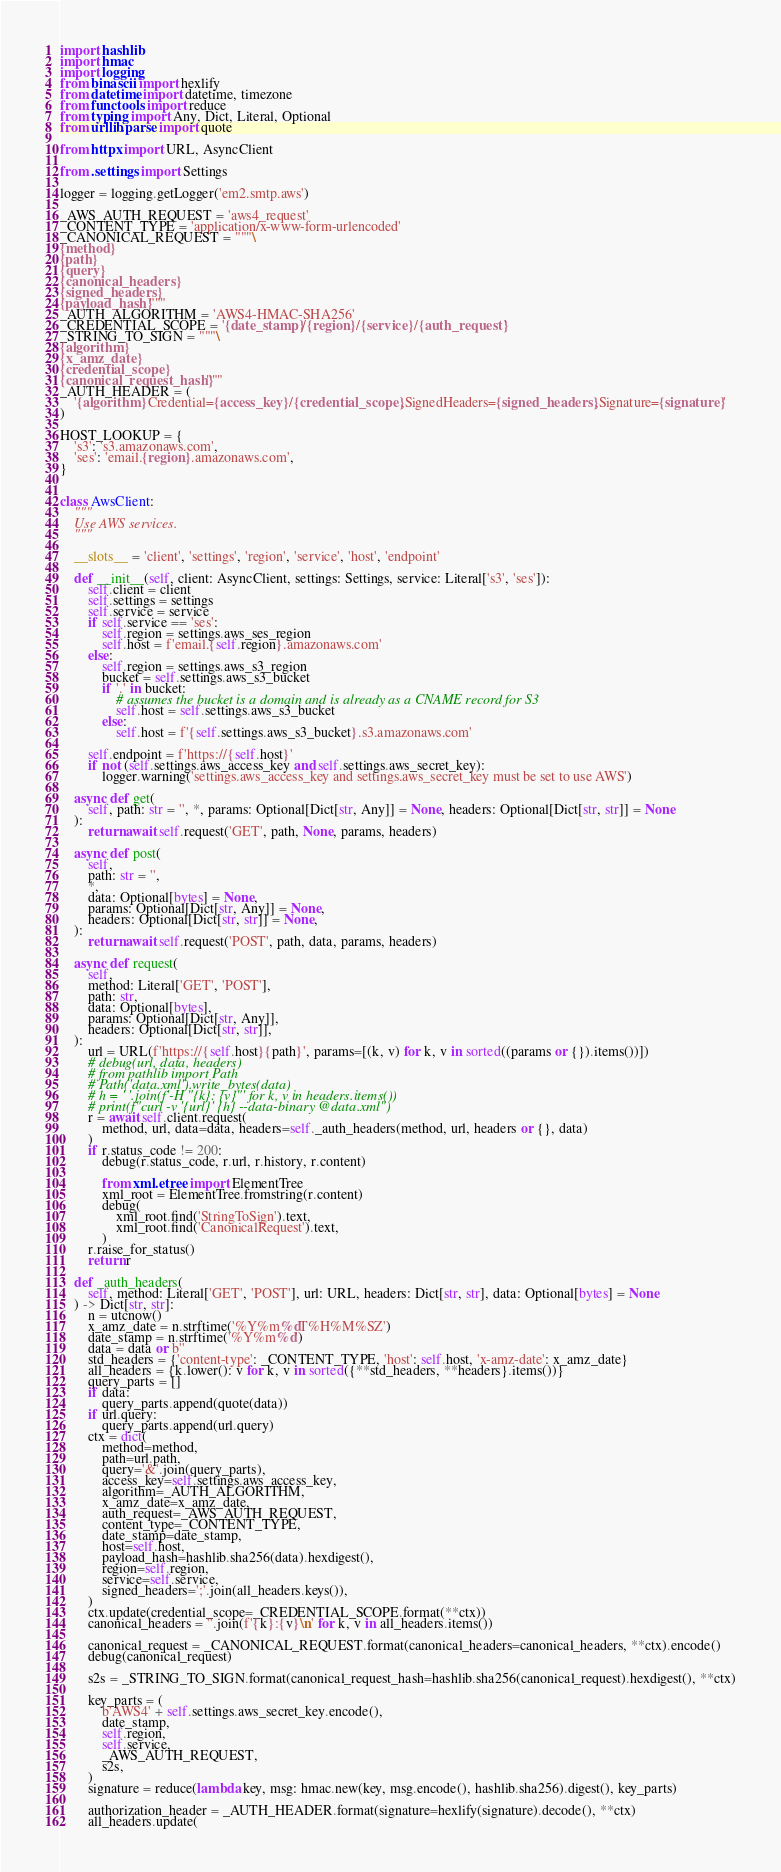Convert code to text. <code><loc_0><loc_0><loc_500><loc_500><_Python_>import hashlib
import hmac
import logging
from binascii import hexlify
from datetime import datetime, timezone
from functools import reduce
from typing import Any, Dict, Literal, Optional
from urllib.parse import quote

from httpx import URL, AsyncClient

from .settings import Settings

logger = logging.getLogger('em2.smtp.aws')

_AWS_AUTH_REQUEST = 'aws4_request'
_CONTENT_TYPE = 'application/x-www-form-urlencoded'
_CANONICAL_REQUEST = """\
{method}
{path}
{query}
{canonical_headers}
{signed_headers}
{payload_hash}"""
_AUTH_ALGORITHM = 'AWS4-HMAC-SHA256'
_CREDENTIAL_SCOPE = '{date_stamp}/{region}/{service}/{auth_request}'
_STRING_TO_SIGN = """\
{algorithm}
{x_amz_date}
{credential_scope}
{canonical_request_hash}"""
_AUTH_HEADER = (
    '{algorithm} Credential={access_key}/{credential_scope},SignedHeaders={signed_headers},Signature={signature}'
)

HOST_LOOKUP = {
    's3': 's3.amazonaws.com',
    'ses': 'email.{region}.amazonaws.com',
}


class AwsClient:
    """
    Use AWS services.
    """

    __slots__ = 'client', 'settings', 'region', 'service', 'host', 'endpoint'

    def __init__(self, client: AsyncClient, settings: Settings, service: Literal['s3', 'ses']):
        self.client = client
        self.settings = settings
        self.service = service
        if self.service == 'ses':
            self.region = settings.aws_ses_region
            self.host = f'email.{self.region}.amazonaws.com'
        else:
            self.region = settings.aws_s3_region
            bucket = self.settings.aws_s3_bucket
            if '.' in bucket:
                # assumes the bucket is a domain and is already as a CNAME record for S3
                self.host = self.settings.aws_s3_bucket
            else:
                self.host = f'{self.settings.aws_s3_bucket}.s3.amazonaws.com'

        self.endpoint = f'https://{self.host}'
        if not (self.settings.aws_access_key and self.settings.aws_secret_key):
            logger.warning('settings.aws_access_key and settings.aws_secret_key must be set to use AWS')

    async def get(
        self, path: str = '', *, params: Optional[Dict[str, Any]] = None, headers: Optional[Dict[str, str]] = None
    ):
        return await self.request('GET', path, None, params, headers)

    async def post(
        self,
        path: str = '',
        *,
        data: Optional[bytes] = None,
        params: Optional[Dict[str, Any]] = None,
        headers: Optional[Dict[str, str]] = None,
    ):
        return await self.request('POST', path, data, params, headers)

    async def request(
        self,
        method: Literal['GET', 'POST'],
        path: str,
        data: Optional[bytes],
        params: Optional[Dict[str, Any]],
        headers: Optional[Dict[str, str]],
    ):
        url = URL(f'https://{self.host}{path}', params=[(k, v) for k, v in sorted((params or {}).items())])
        # debug(url, data, headers)
        # from pathlib import Path
        # Path('data.xml').write_bytes(data)
        # h = ' '.join(f'-H "{k}: {v}"' for k, v in headers.items())
        # print(f"curl -v '{url}' {h} --data-binary @data.xml")
        r = await self.client.request(
            method, url, data=data, headers=self._auth_headers(method, url, headers or {}, data)
        )
        if r.status_code != 200:
            debug(r.status_code, r.url, r.history, r.content)

            from xml.etree import ElementTree
            xml_root = ElementTree.fromstring(r.content)
            debug(
                xml_root.find('StringToSign').text,
                xml_root.find('CanonicalRequest').text,
            )
        r.raise_for_status()
        return r

    def _auth_headers(
        self, method: Literal['GET', 'POST'], url: URL, headers: Dict[str, str], data: Optional[bytes] = None
    ) -> Dict[str, str]:
        n = utcnow()
        x_amz_date = n.strftime('%Y%m%dT%H%M%SZ')
        date_stamp = n.strftime('%Y%m%d')
        data = data or b''
        std_headers = {'content-type': _CONTENT_TYPE, 'host': self.host, 'x-amz-date': x_amz_date}
        all_headers = {k.lower(): v for k, v in sorted({**std_headers, **headers}.items())}
        query_parts = []
        if data:
            query_parts.append(quote(data))
        if url.query:
            query_parts.append(url.query)
        ctx = dict(
            method=method,
            path=url.path,
            query='&'.join(query_parts),
            access_key=self.settings.aws_access_key,
            algorithm=_AUTH_ALGORITHM,
            x_amz_date=x_amz_date,
            auth_request=_AWS_AUTH_REQUEST,
            content_type=_CONTENT_TYPE,
            date_stamp=date_stamp,
            host=self.host,
            payload_hash=hashlib.sha256(data).hexdigest(),
            region=self.region,
            service=self.service,
            signed_headers=';'.join(all_headers.keys()),
        )
        ctx.update(credential_scope=_CREDENTIAL_SCOPE.format(**ctx))
        canonical_headers = ''.join(f'{k}:{v}\n' for k, v in all_headers.items())

        canonical_request = _CANONICAL_REQUEST.format(canonical_headers=canonical_headers, **ctx).encode()
        debug(canonical_request)

        s2s = _STRING_TO_SIGN.format(canonical_request_hash=hashlib.sha256(canonical_request).hexdigest(), **ctx)

        key_parts = (
            b'AWS4' + self.settings.aws_secret_key.encode(),
            date_stamp,
            self.region,
            self.service,
            _AWS_AUTH_REQUEST,
            s2s,
        )
        signature = reduce(lambda key, msg: hmac.new(key, msg.encode(), hashlib.sha256).digest(), key_parts)

        authorization_header = _AUTH_HEADER.format(signature=hexlify(signature).decode(), **ctx)
        all_headers.update(</code> 